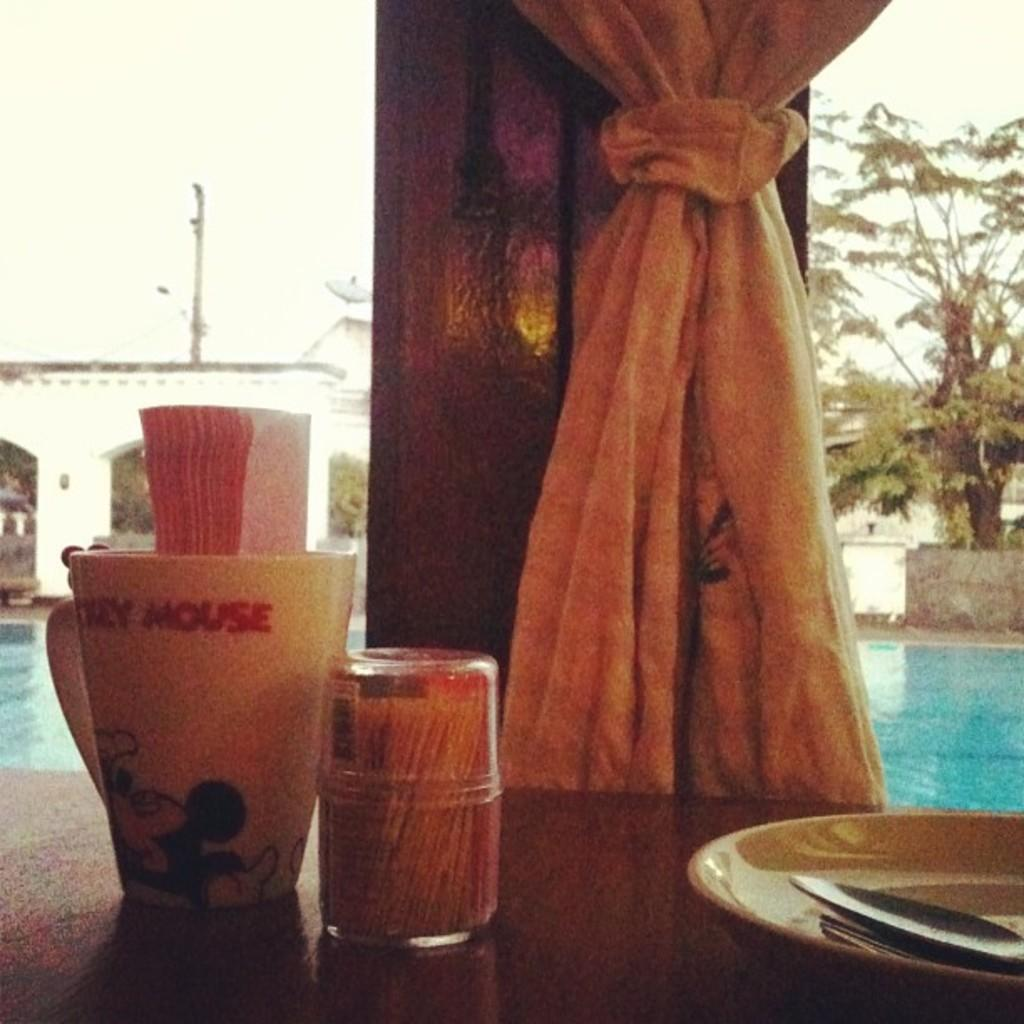What is one of the objects placed on the table in the image? There is a cup in the image. What else can be found on the table in the image? There are tissues, toothpicks, a plate, and spoons in the image. Can you describe the background of the image? The background of the image includes water, a curtain, trees, an arch, and the sky. What type of current is flowing through the comb in the image? There is no comb present in the image, so it is not possible to determine if any current is flowing through it. 